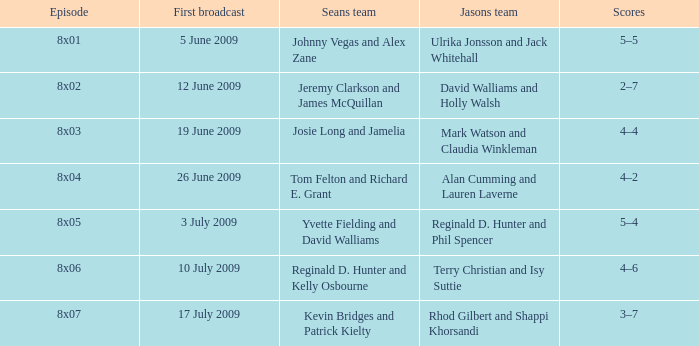Who was on Jason's team for the 12 June 2009 episode? David Walliams and Holly Walsh. 